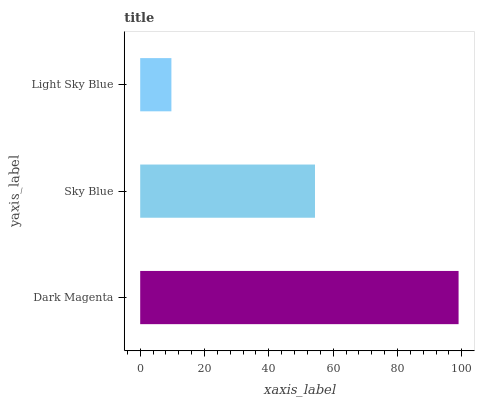Is Light Sky Blue the minimum?
Answer yes or no. Yes. Is Dark Magenta the maximum?
Answer yes or no. Yes. Is Sky Blue the minimum?
Answer yes or no. No. Is Sky Blue the maximum?
Answer yes or no. No. Is Dark Magenta greater than Sky Blue?
Answer yes or no. Yes. Is Sky Blue less than Dark Magenta?
Answer yes or no. Yes. Is Sky Blue greater than Dark Magenta?
Answer yes or no. No. Is Dark Magenta less than Sky Blue?
Answer yes or no. No. Is Sky Blue the high median?
Answer yes or no. Yes. Is Sky Blue the low median?
Answer yes or no. Yes. Is Dark Magenta the high median?
Answer yes or no. No. Is Light Sky Blue the low median?
Answer yes or no. No. 